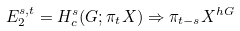<formula> <loc_0><loc_0><loc_500><loc_500>E _ { 2 } ^ { s , t } = H _ { c } ^ { s } ( G ; \pi _ { t } X ) \Rightarrow \pi _ { t - s } X ^ { h G }</formula> 